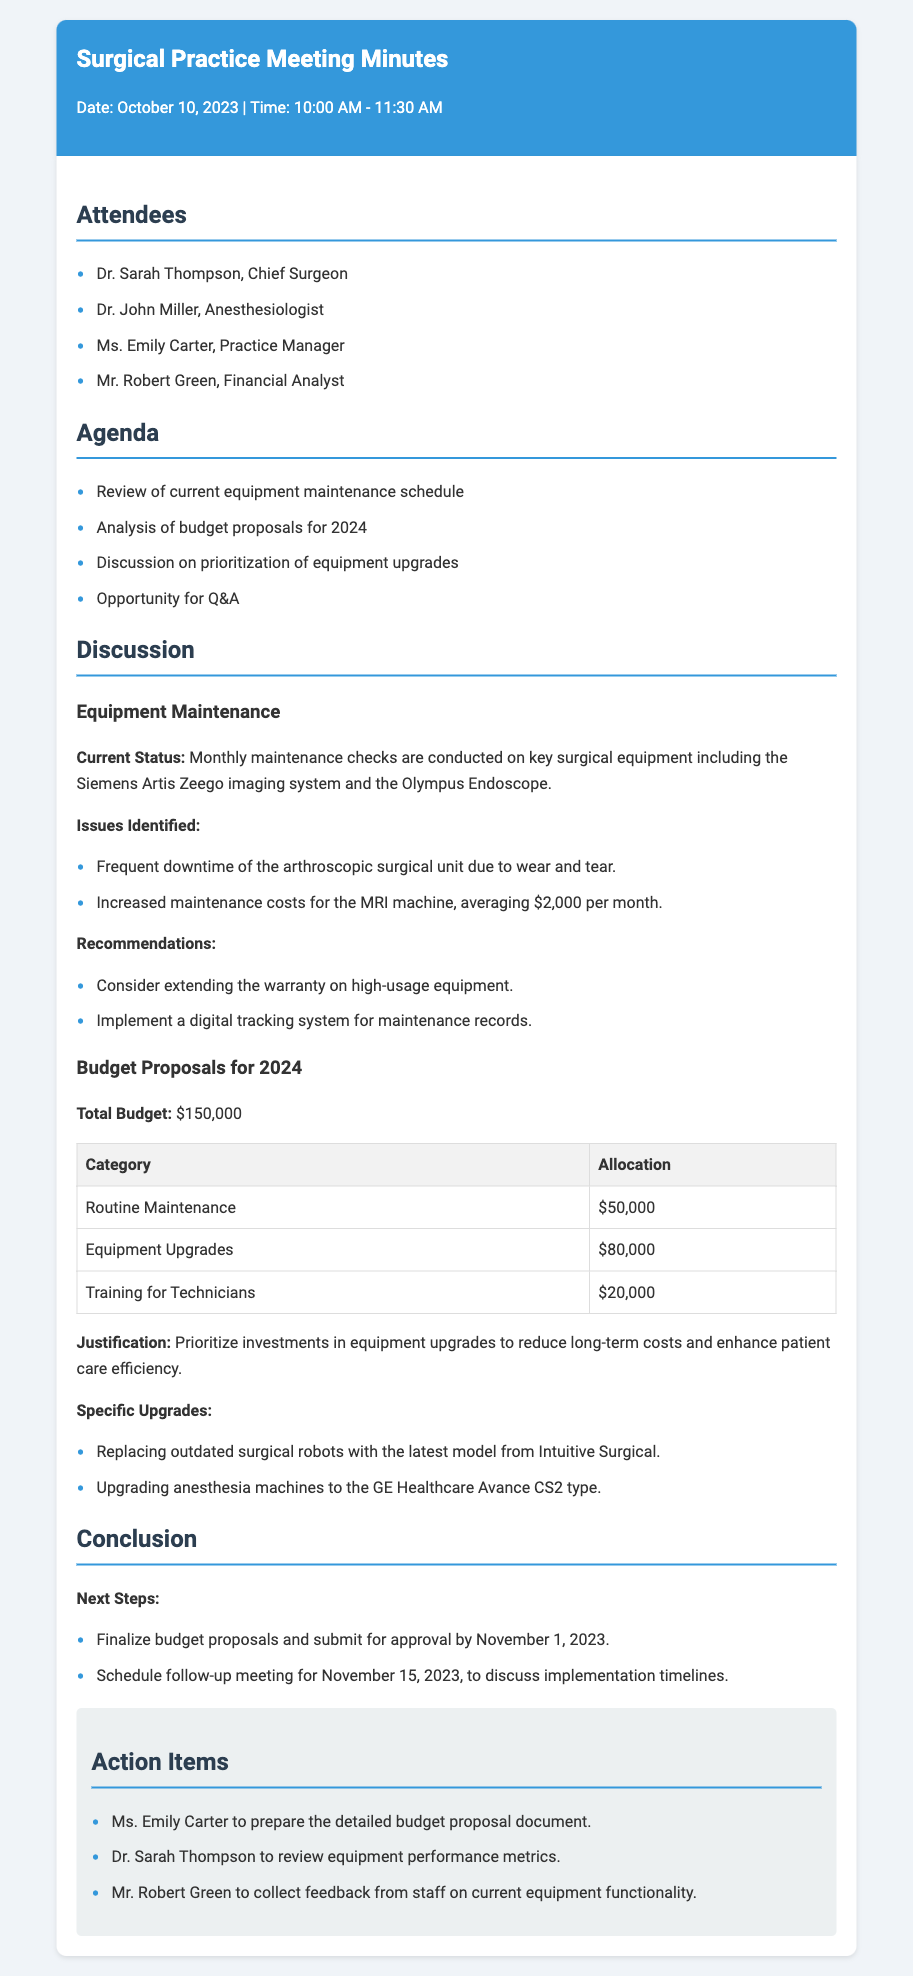What is the date of the meeting? The date of the meeting is mentioned at the top of the document as October 10, 2023.
Answer: October 10, 2023 Who is the Chief Surgeon? The document lists Dr. Sarah Thompson as the Chief Surgeon among attendees.
Answer: Dr. Sarah Thompson What is the total budget for 2024? The total budget is explicitly stated in the section about budget proposals for 2024 as $150,000.
Answer: $150,000 How much is allocated for routine maintenance? The budget table specifies that $50,000 is allocated for routine maintenance.
Answer: $50,000 What issue was identified regarding the MRI machine? The document states that there are increased maintenance costs for the MRI machine, which is averaging $2,000 per month.
Answer: $2,000 What is one of the specific upgrades proposed? One specific upgrade mentioned is the replacement of outdated surgical robots with the latest model from Intuitive Surgical.
Answer: Replacing outdated surgical robots When is the follow-up meeting scheduled? The document outlines that the follow-up meeting is scheduled for November 15, 2023.
Answer: November 15, 2023 Who is responsible for preparing the detailed budget proposal document? The action items section indicates that Ms. Emily Carter is assigned to prepare the detailed budget proposal document.
Answer: Ms. Emily Carter What is the justification for prioritizing equipment upgrades? The document notes that the justification is to reduce long-term costs and enhance patient care efficiency.
Answer: Reduce long-term costs and enhance patient care efficiency 